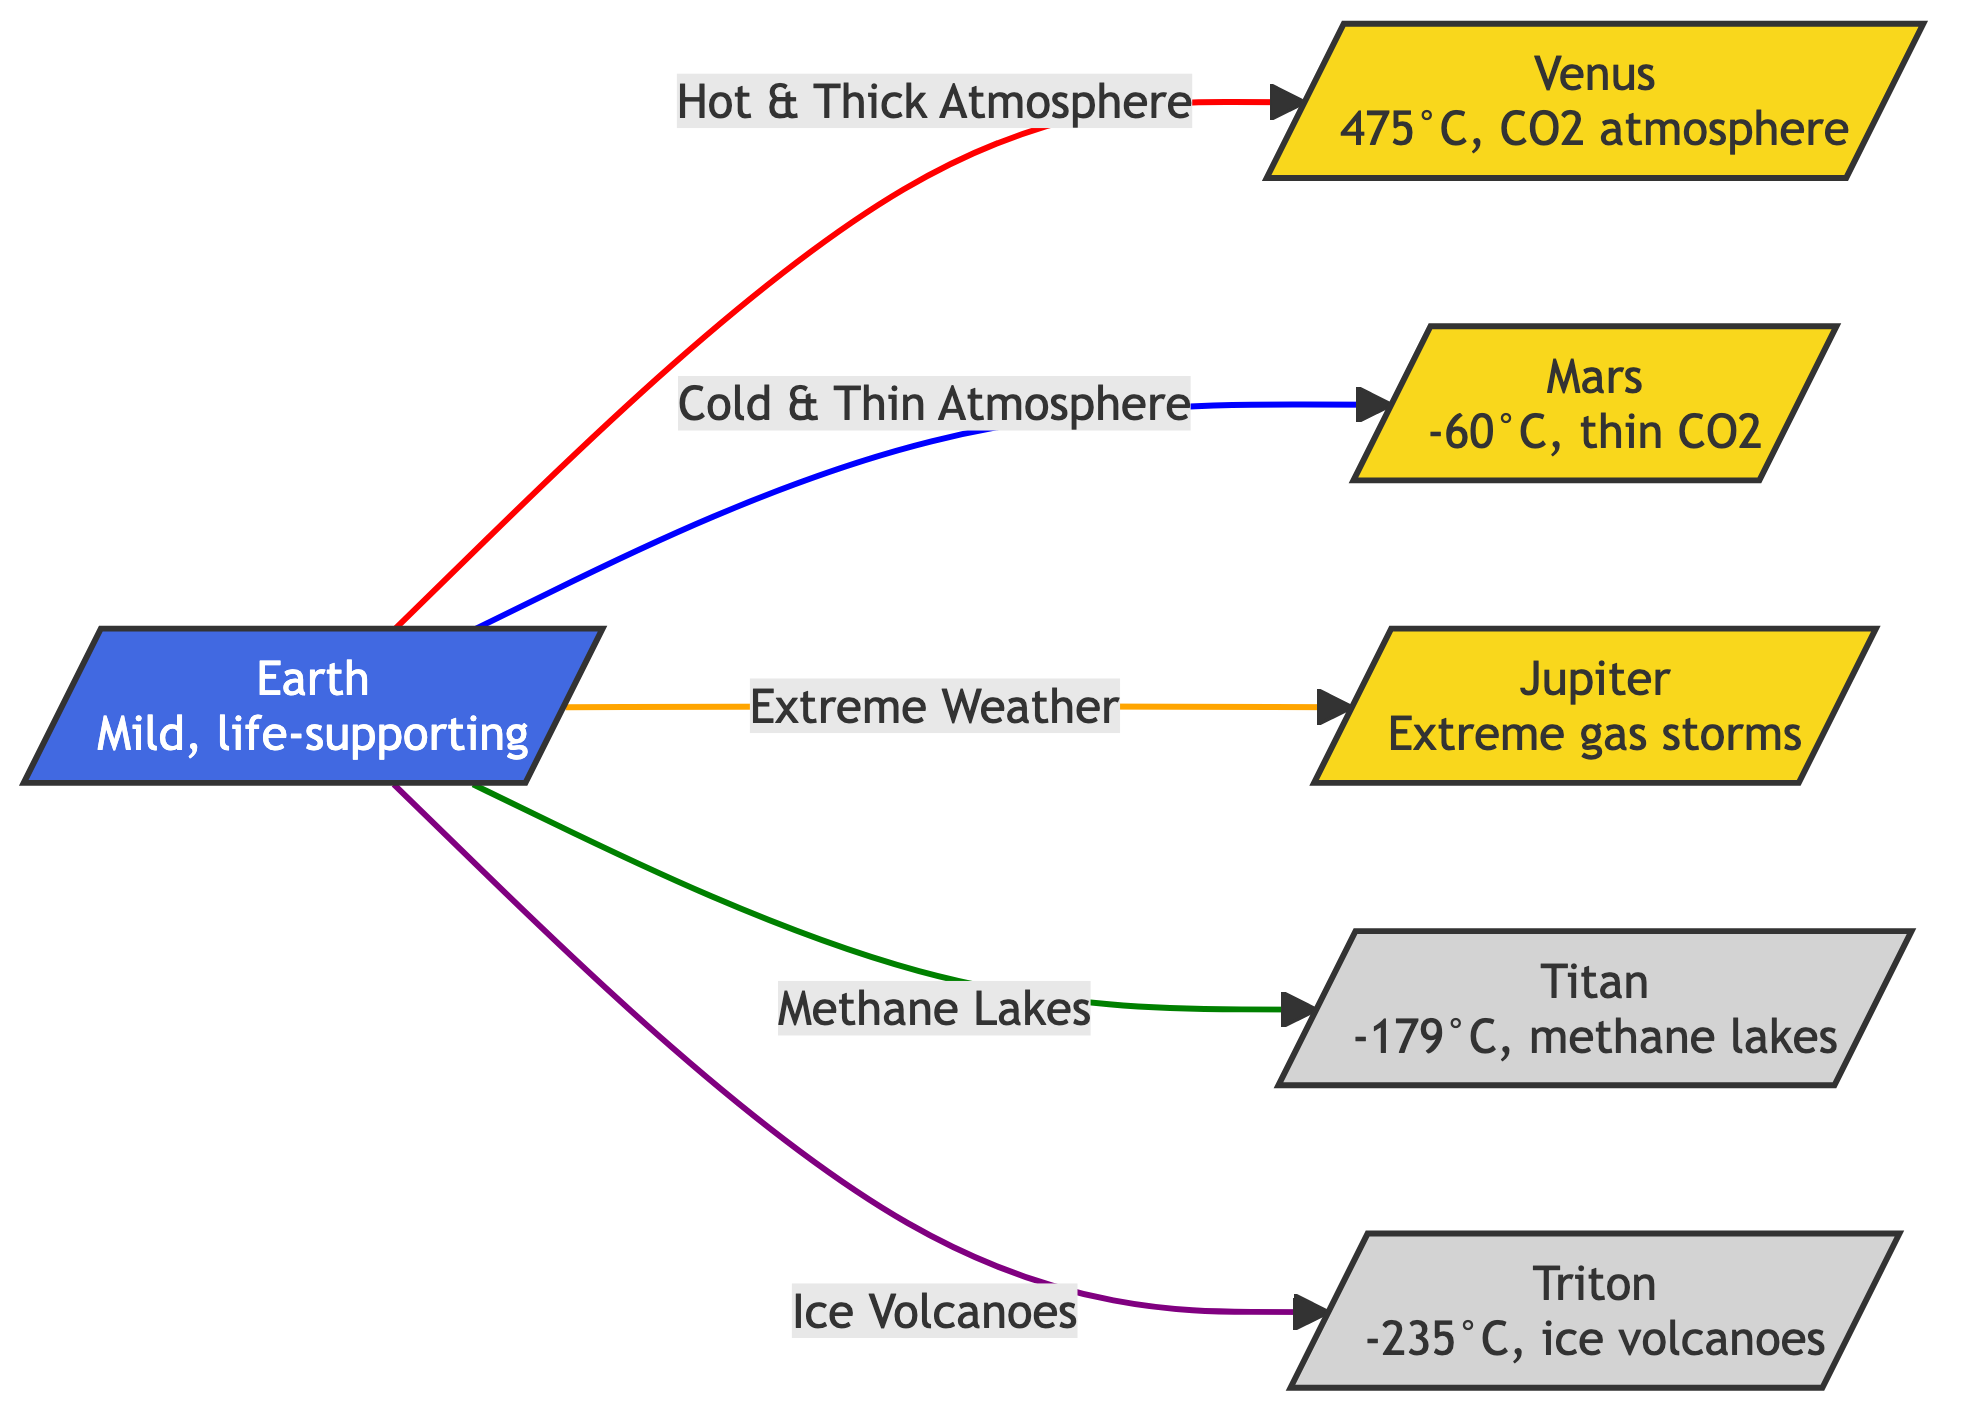What is the surface temperature of Venus? The diagram indicates that Venus has a surface temperature of 475°C. This information is directly stated in the label for Venus.
Answer: 475°C What kind of atmosphere does Mars have? The diagram specifies that Mars has a "thin CO2" atmosphere. This is displayed in the label for Mars.
Answer: thin CO2 What extreme condition is associated with Jupiter? According to the diagram, Jupiter is associated with "Extreme gas storms," which is noted in its label.
Answer: Extreme gas storms How many planetary bodies are connected to Earth in the diagram? There are five bodies shown (Venus, Mars, Jupiter, Titan, and Triton) connected to Earth, indicating the different extremes that exist compared to Earth.
Answer: 5 What condition do Titan's lakes consist of? Titan's lakes are described as "methane lakes" in the diagram, which shows a unique feature distinguishing it from Earth.
Answer: methane lakes Which celestial body has ice volcanoes? The diagram mentions that Triton is known for "ice volcanoes," which is stated in its description.
Answer: Triton Which planet has a cold and thin atmosphere? The diagram states that Mars has a "Cold & Thin Atmosphere." The relationship is indicated through the arrow leading from Earth to Mars.
Answer: Mars What is highlighted in the connection from Earth to Titan? The diagram specifically highlights "Methane Lakes" in the connection from Earth to Titan, emphasizing the extreme conditions found on Titan.
Answer: Methane Lakes What color represents Earth in the diagram? Earth is represented in blue, as indicated by the defined class for Earth within the diagram.
Answer: blue 